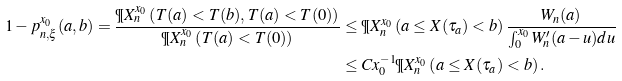Convert formula to latex. <formula><loc_0><loc_0><loc_500><loc_500>1 - p _ { n , \xi } ^ { x _ { 0 } } ( a , b ) = \frac { \P X _ { n } ^ { x _ { 0 } } \left ( T ( a ) < T ( b ) , T ( a ) < T ( 0 ) \right ) } { \P X _ { n } ^ { x _ { 0 } } \left ( T ( a ) < T ( 0 ) \right ) } & \leq \P X _ { n } ^ { x _ { 0 } } \left ( a \leq X ( \tau _ { a } ) < b \right ) \frac { W _ { n } ( a ) } { \int _ { 0 } ^ { x _ { 0 } } W ^ { \prime } _ { n } ( a - u ) d u } \\ & \leq C x _ { 0 } ^ { - 1 } \P X _ { n } ^ { x _ { 0 } } \left ( a \leq X ( \tau _ { a } ) < b \right ) .</formula> 